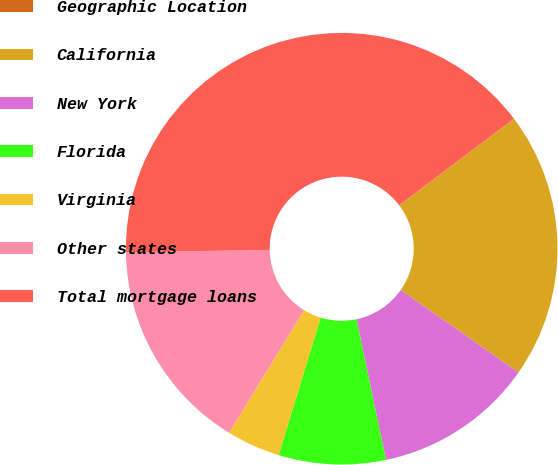Convert chart. <chart><loc_0><loc_0><loc_500><loc_500><pie_chart><fcel>Geographic Location<fcel>California<fcel>New York<fcel>Florida<fcel>Virginia<fcel>Other states<fcel>Total mortgage loans<nl><fcel>0.01%<fcel>19.99%<fcel>12.0%<fcel>8.01%<fcel>4.01%<fcel>16.0%<fcel>39.97%<nl></chart> 